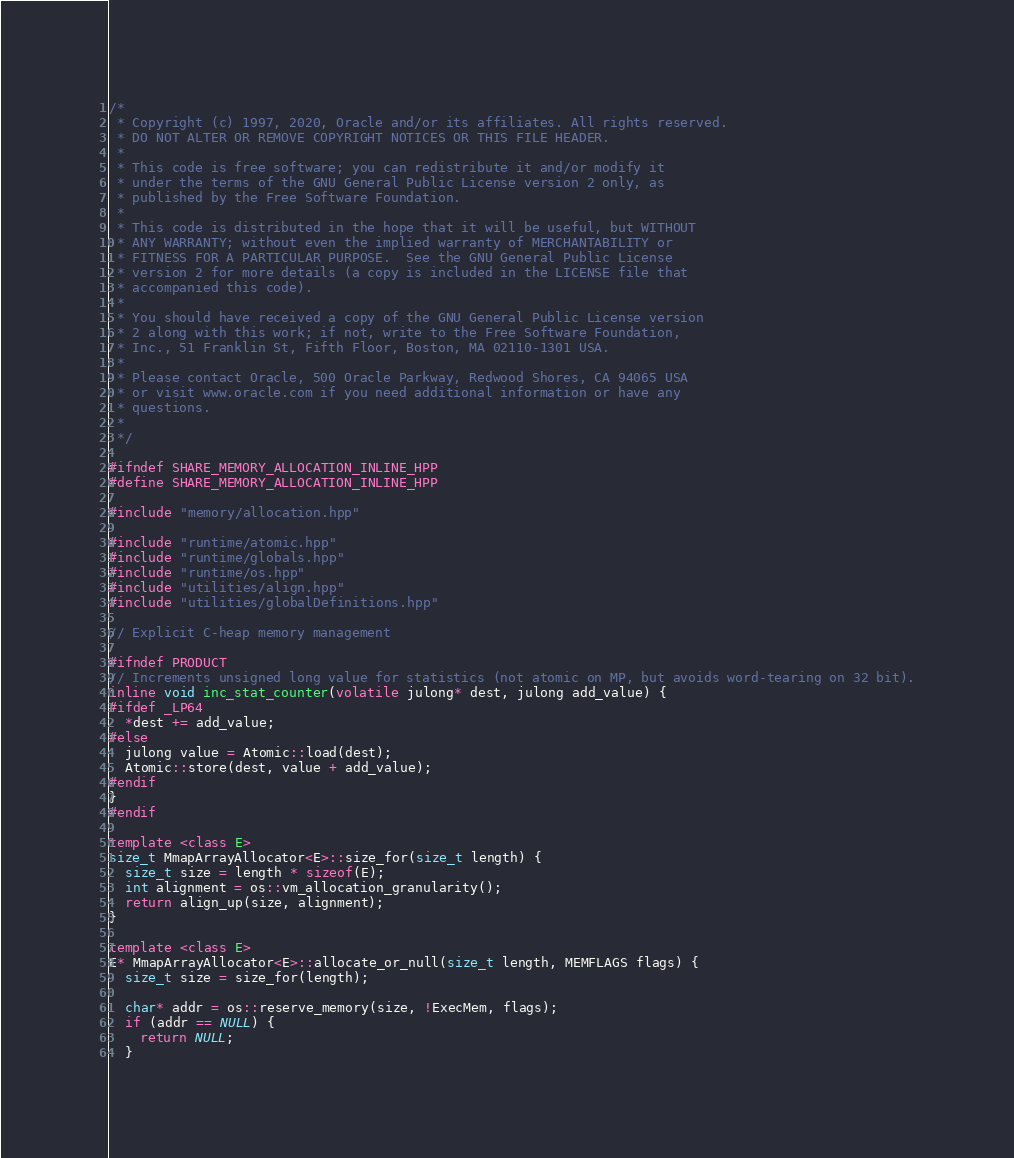<code> <loc_0><loc_0><loc_500><loc_500><_C++_>/*
 * Copyright (c) 1997, 2020, Oracle and/or its affiliates. All rights reserved.
 * DO NOT ALTER OR REMOVE COPYRIGHT NOTICES OR THIS FILE HEADER.
 *
 * This code is free software; you can redistribute it and/or modify it
 * under the terms of the GNU General Public License version 2 only, as
 * published by the Free Software Foundation.
 *
 * This code is distributed in the hope that it will be useful, but WITHOUT
 * ANY WARRANTY; without even the implied warranty of MERCHANTABILITY or
 * FITNESS FOR A PARTICULAR PURPOSE.  See the GNU General Public License
 * version 2 for more details (a copy is included in the LICENSE file that
 * accompanied this code).
 *
 * You should have received a copy of the GNU General Public License version
 * 2 along with this work; if not, write to the Free Software Foundation,
 * Inc., 51 Franklin St, Fifth Floor, Boston, MA 02110-1301 USA.
 *
 * Please contact Oracle, 500 Oracle Parkway, Redwood Shores, CA 94065 USA
 * or visit www.oracle.com if you need additional information or have any
 * questions.
 *
 */

#ifndef SHARE_MEMORY_ALLOCATION_INLINE_HPP
#define SHARE_MEMORY_ALLOCATION_INLINE_HPP

#include "memory/allocation.hpp"

#include "runtime/atomic.hpp"
#include "runtime/globals.hpp"
#include "runtime/os.hpp"
#include "utilities/align.hpp"
#include "utilities/globalDefinitions.hpp"

// Explicit C-heap memory management

#ifndef PRODUCT
// Increments unsigned long value for statistics (not atomic on MP, but avoids word-tearing on 32 bit).
inline void inc_stat_counter(volatile julong* dest, julong add_value) {
#ifdef _LP64
  *dest += add_value;
#else
  julong value = Atomic::load(dest);
  Atomic::store(dest, value + add_value);
#endif
}
#endif

template <class E>
size_t MmapArrayAllocator<E>::size_for(size_t length) {
  size_t size = length * sizeof(E);
  int alignment = os::vm_allocation_granularity();
  return align_up(size, alignment);
}

template <class E>
E* MmapArrayAllocator<E>::allocate_or_null(size_t length, MEMFLAGS flags) {
  size_t size = size_for(length);

  char* addr = os::reserve_memory(size, !ExecMem, flags);
  if (addr == NULL) {
    return NULL;
  }
</code> 